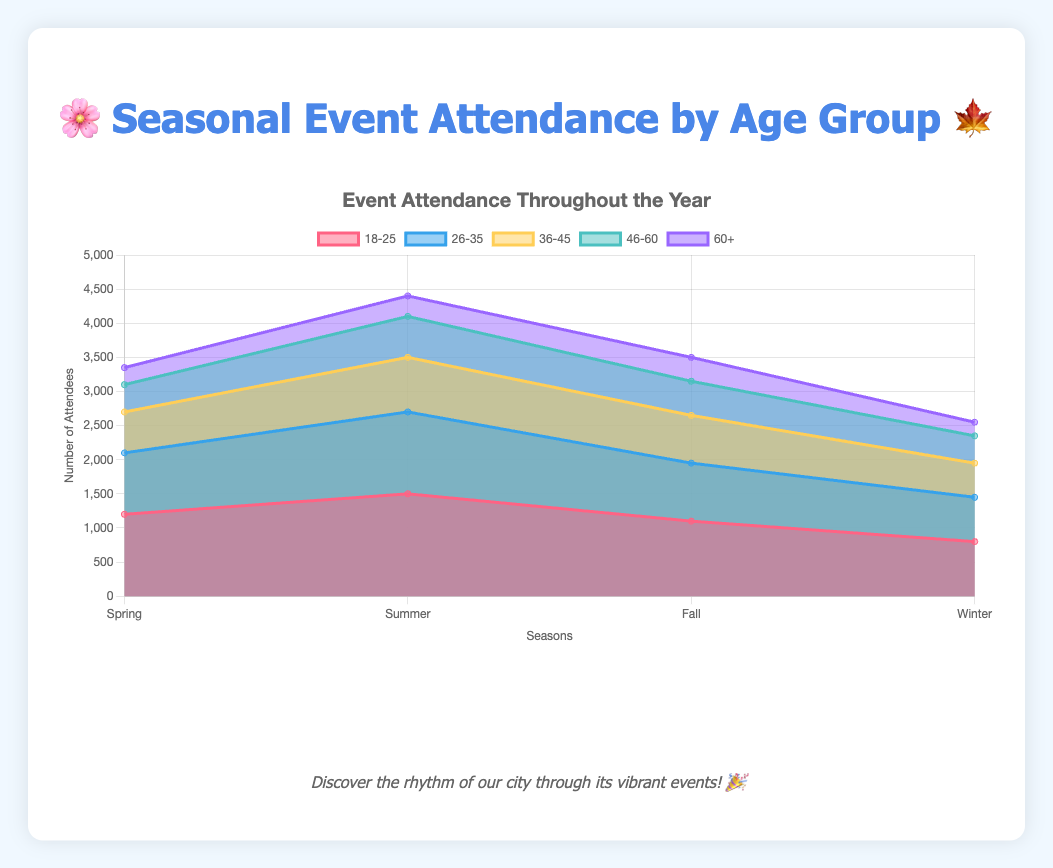What is the peak attendance for the 60+ age group and in which season does it occur? The highest point on the 60+ age group's line is 350, which happens in the fall season.
Answer: 350 in the fall Which season had the highest overall event attendance for the 18-25 age group? By comparing the height of the area for the 18-25 age group across all seasons, we see that summer has the highest attendance at 1500.
Answer: Summer Compare the attendance of the 36-45 age group between Spring and Winter. In Spring, the 36-45 group attendance is 600, while in Winter it is 500. Therefore, there are 100 more attendees in Spring.
Answer: 100 more in Spring What is the total attendance for the age group 26-35 across all seasons? Summing the values: 900 (Spring) + 1200 (Summer) + 850 (Fall) + 650 (Winter) gives 3600.
Answer: 3600 During which season is the difference between the 18-25 and 46-60 age group attendances the largest? Calculating the differences: Spring (1200-400=800), Summer (1500-600=900), Fall (1100-500=600), Winter (800-400=400). The largest difference is in Summer.
Answer: Summer What is the average attendance for the 46-60 age group throughout the year? Sum the attendances (400 + 600 + 500 + 400) which equals 1900, and then divide by 4 (the number of seasons), resulting in 475.
Answer: 475 How does the attendance trend for the 26-35 age group change from Spring to Winter? The attendance starts at 900 in Spring, increases to 1200 in Summer, decreases to 850 in Fall, and further decreases to 650 in Winter.
Answer: Decreases overall Which age group has the smallest decline in attendance from Summer to Winter? 18-25: 700 decline, 26-35: 550 decline, 36-45: 300 decline, 46-60: 200 decline, 60+: 100 decline. So, the 60+ group has the smallest decline.
Answer: 60+ What event has the highest overall attendance, and in which season does it occur? Summing up all age groups per event: Spring (3350), Summer (4400), Fall (3500), Winter (2550). The highest attendance event is the Downtown Food Truck Rally in Summer.
Answer: Downtown Food Truck Rally in Summer 